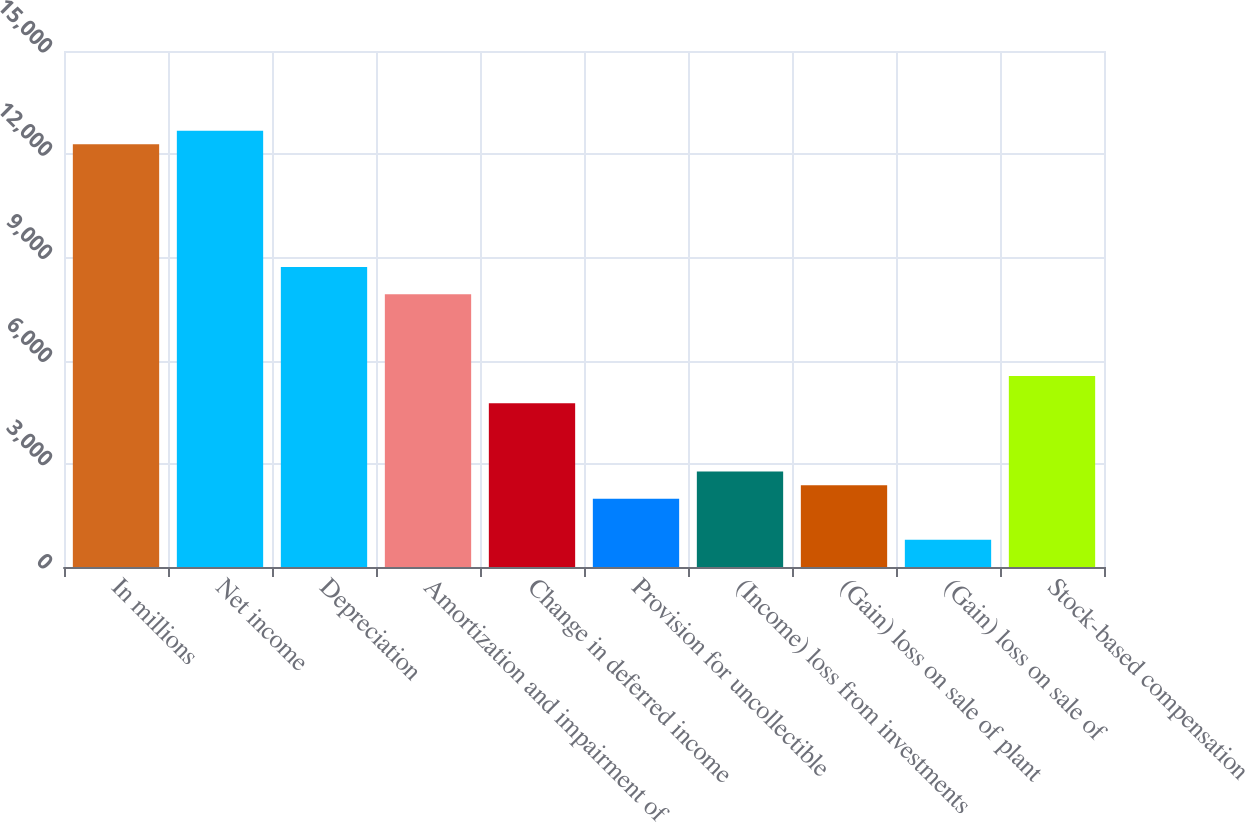<chart> <loc_0><loc_0><loc_500><loc_500><bar_chart><fcel>In millions<fcel>Net income<fcel>Depreciation<fcel>Amortization and impairment of<fcel>Change in deferred income<fcel>Provision for uncollectible<fcel>(Income) loss from investments<fcel>(Gain) loss on sale of plant<fcel>(Gain) loss on sale of<fcel>Stock-based compensation<nl><fcel>12286.3<fcel>12682.6<fcel>8719.6<fcel>7927<fcel>4756.6<fcel>1982.5<fcel>2775.1<fcel>2378.8<fcel>793.6<fcel>5549.2<nl></chart> 